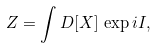<formula> <loc_0><loc_0><loc_500><loc_500>Z = \int D [ X ] \, \exp i I ,</formula> 